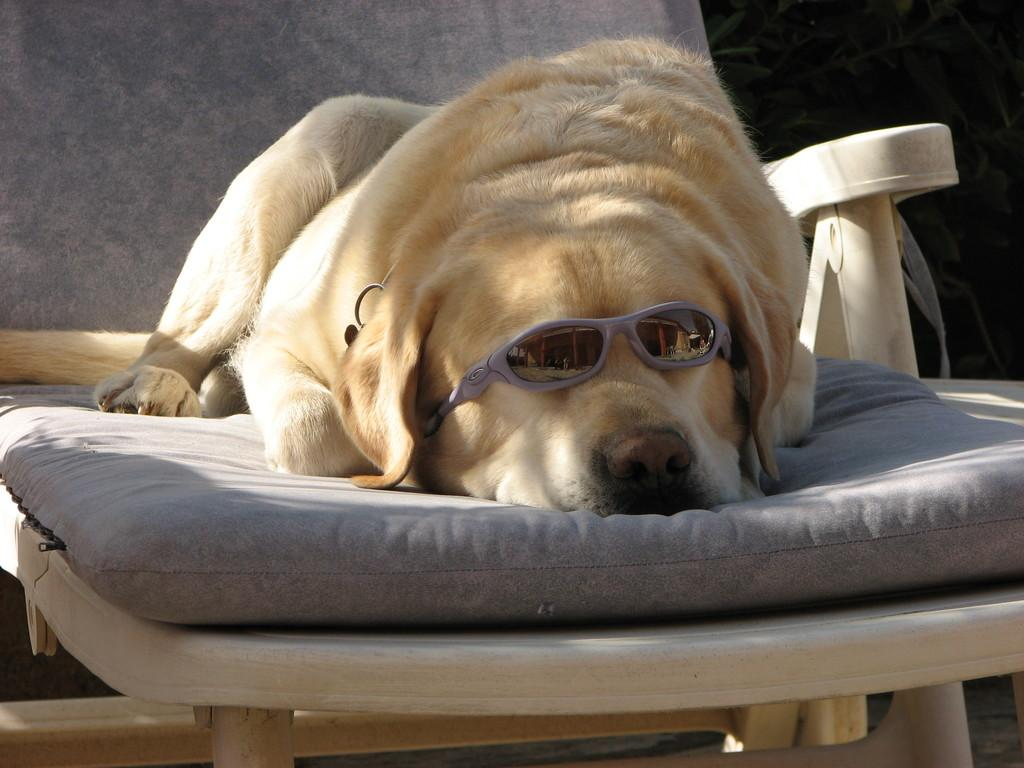What animal can be seen in the image? There is a dog in the image. What is the dog doing in the image? The dog is sleeping in a chair. What accessory is the dog wearing in the image? The dog is wearing spectacles. What type of drink is the dog holding in the image? There is no drink present in the image; the dog is wearing spectacles and sleeping in a chair. 